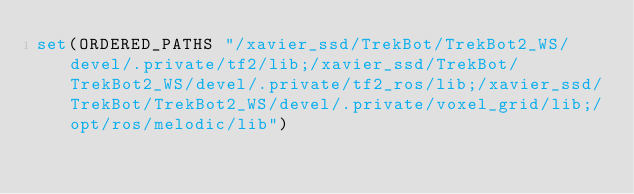Convert code to text. <code><loc_0><loc_0><loc_500><loc_500><_CMake_>set(ORDERED_PATHS "/xavier_ssd/TrekBot/TrekBot2_WS/devel/.private/tf2/lib;/xavier_ssd/TrekBot/TrekBot2_WS/devel/.private/tf2_ros/lib;/xavier_ssd/TrekBot/TrekBot2_WS/devel/.private/voxel_grid/lib;/opt/ros/melodic/lib")</code> 